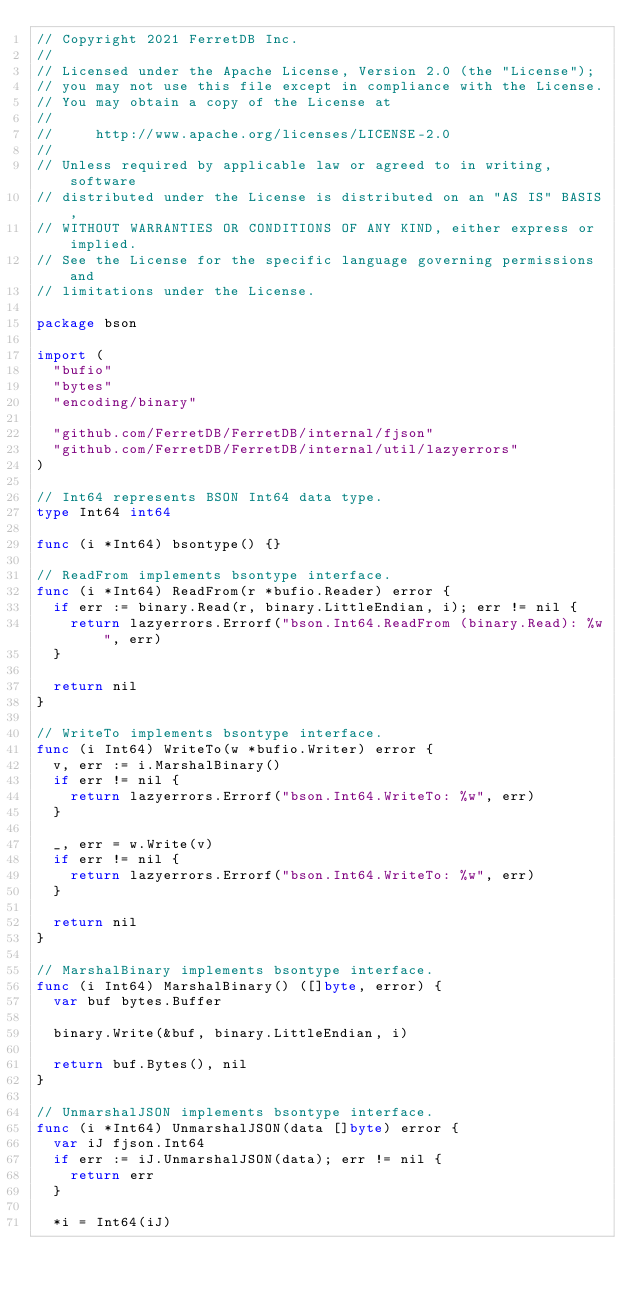<code> <loc_0><loc_0><loc_500><loc_500><_Go_>// Copyright 2021 FerretDB Inc.
//
// Licensed under the Apache License, Version 2.0 (the "License");
// you may not use this file except in compliance with the License.
// You may obtain a copy of the License at
//
//     http://www.apache.org/licenses/LICENSE-2.0
//
// Unless required by applicable law or agreed to in writing, software
// distributed under the License is distributed on an "AS IS" BASIS,
// WITHOUT WARRANTIES OR CONDITIONS OF ANY KIND, either express or implied.
// See the License for the specific language governing permissions and
// limitations under the License.

package bson

import (
	"bufio"
	"bytes"
	"encoding/binary"

	"github.com/FerretDB/FerretDB/internal/fjson"
	"github.com/FerretDB/FerretDB/internal/util/lazyerrors"
)

// Int64 represents BSON Int64 data type.
type Int64 int64

func (i *Int64) bsontype() {}

// ReadFrom implements bsontype interface.
func (i *Int64) ReadFrom(r *bufio.Reader) error {
	if err := binary.Read(r, binary.LittleEndian, i); err != nil {
		return lazyerrors.Errorf("bson.Int64.ReadFrom (binary.Read): %w", err)
	}

	return nil
}

// WriteTo implements bsontype interface.
func (i Int64) WriteTo(w *bufio.Writer) error {
	v, err := i.MarshalBinary()
	if err != nil {
		return lazyerrors.Errorf("bson.Int64.WriteTo: %w", err)
	}

	_, err = w.Write(v)
	if err != nil {
		return lazyerrors.Errorf("bson.Int64.WriteTo: %w", err)
	}

	return nil
}

// MarshalBinary implements bsontype interface.
func (i Int64) MarshalBinary() ([]byte, error) {
	var buf bytes.Buffer

	binary.Write(&buf, binary.LittleEndian, i)

	return buf.Bytes(), nil
}

// UnmarshalJSON implements bsontype interface.
func (i *Int64) UnmarshalJSON(data []byte) error {
	var iJ fjson.Int64
	if err := iJ.UnmarshalJSON(data); err != nil {
		return err
	}

	*i = Int64(iJ)</code> 